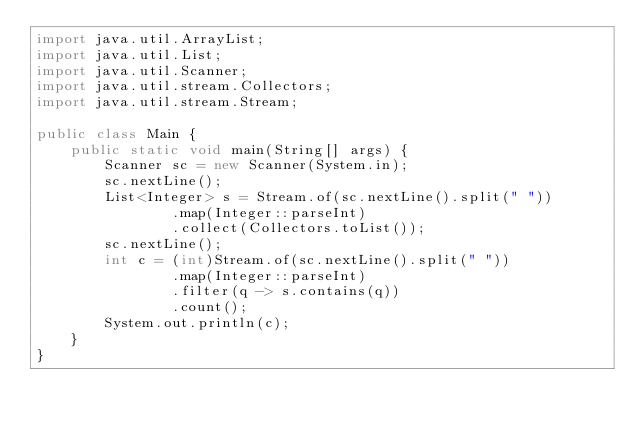Convert code to text. <code><loc_0><loc_0><loc_500><loc_500><_Java_>import java.util.ArrayList;
import java.util.List;
import java.util.Scanner;
import java.util.stream.Collectors;
import java.util.stream.Stream;

public class Main {
    public static void main(String[] args) {
        Scanner sc = new Scanner(System.in);
        sc.nextLine();
        List<Integer> s = Stream.of(sc.nextLine().split(" "))
                .map(Integer::parseInt)
                .collect(Collectors.toList());
        sc.nextLine();
        int c = (int)Stream.of(sc.nextLine().split(" "))
                .map(Integer::parseInt)
                .filter(q -> s.contains(q))
                .count();
        System.out.println(c);
    }
}


</code> 